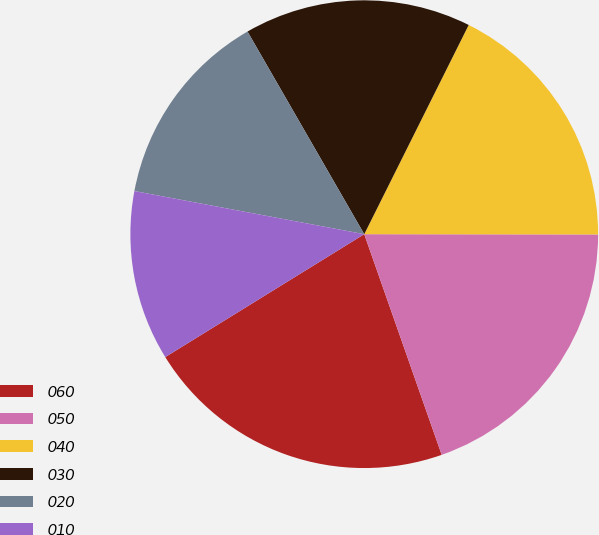Convert chart. <chart><loc_0><loc_0><loc_500><loc_500><pie_chart><fcel>060<fcel>050<fcel>040<fcel>030<fcel>020<fcel>010<nl><fcel>21.57%<fcel>19.61%<fcel>17.65%<fcel>15.69%<fcel>13.73%<fcel>11.76%<nl></chart> 